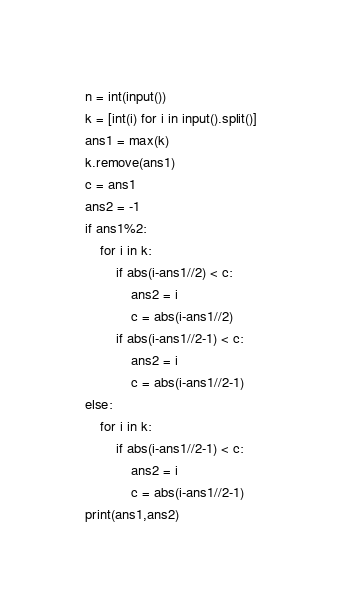<code> <loc_0><loc_0><loc_500><loc_500><_Python_>n = int(input())
k = [int(i) for i in input().split()]
ans1 = max(k)
k.remove(ans1)
c = ans1
ans2 = -1
if ans1%2:
    for i in k:
        if abs(i-ans1//2) < c:
            ans2 = i
            c = abs(i-ans1//2)
        if abs(i-ans1//2-1) < c:
            ans2 = i
            c = abs(i-ans1//2-1)
else:
    for i in k:
        if abs(i-ans1//2-1) < c:
            ans2 = i
            c = abs(i-ans1//2-1)
print(ans1,ans2)

</code> 